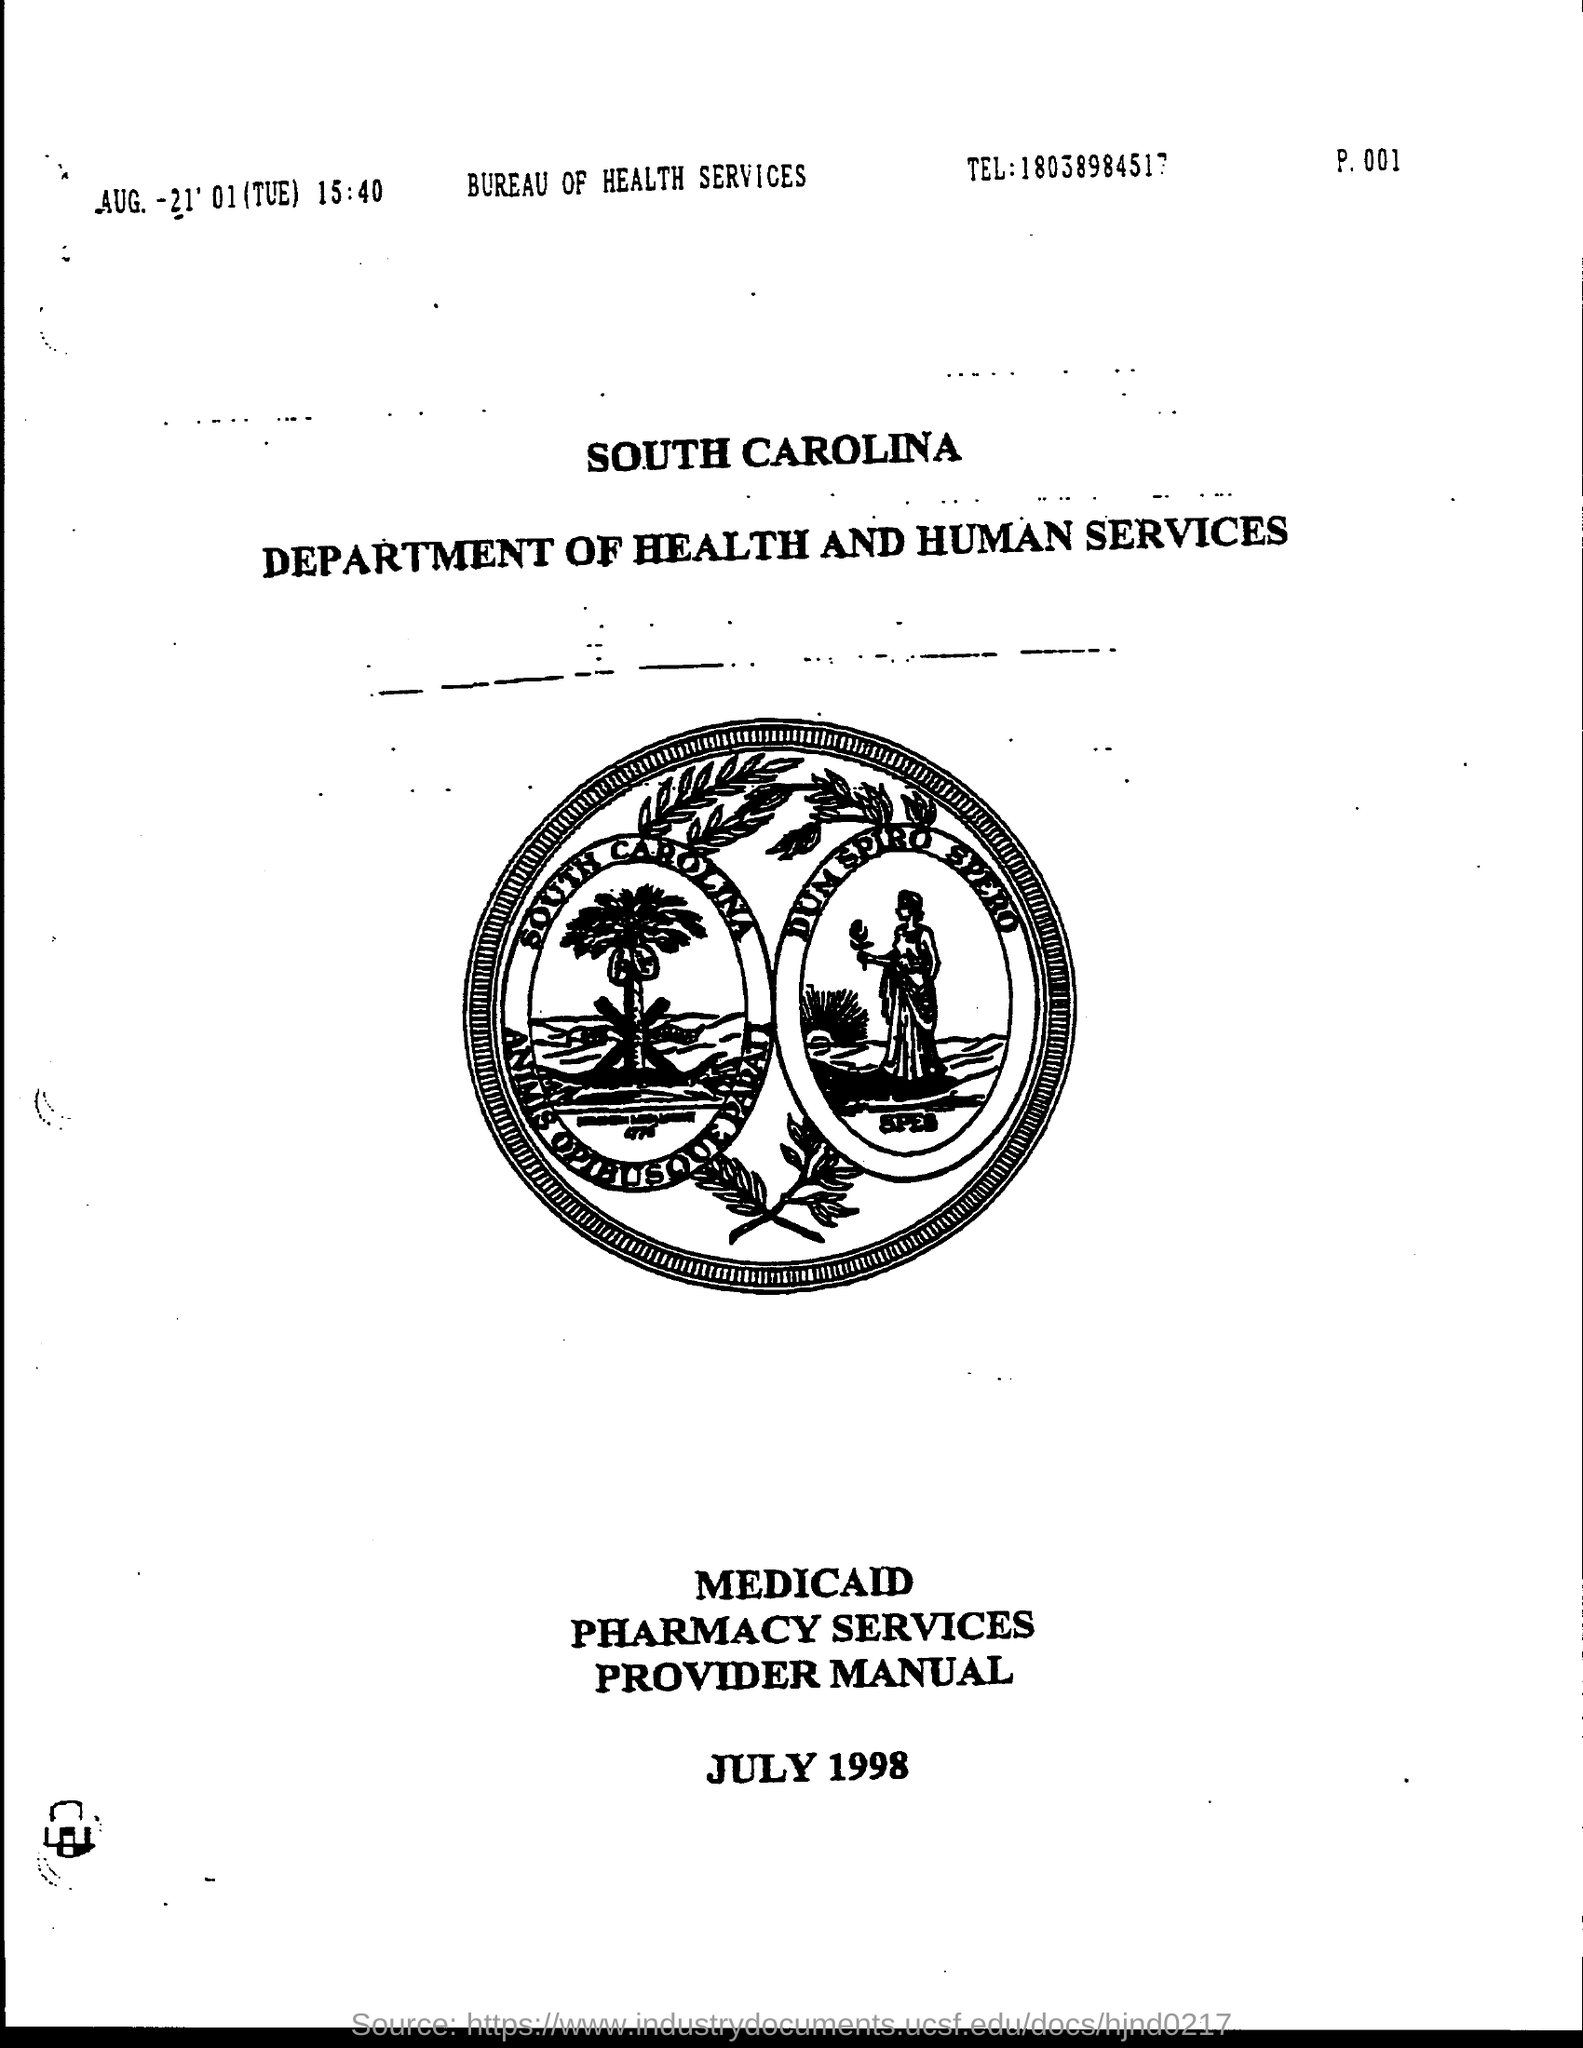What is tel. of bureau of health services ?
Provide a succinct answer. 18038984517. 